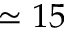Convert formula to latex. <formula><loc_0><loc_0><loc_500><loc_500>\simeq 1 5</formula> 